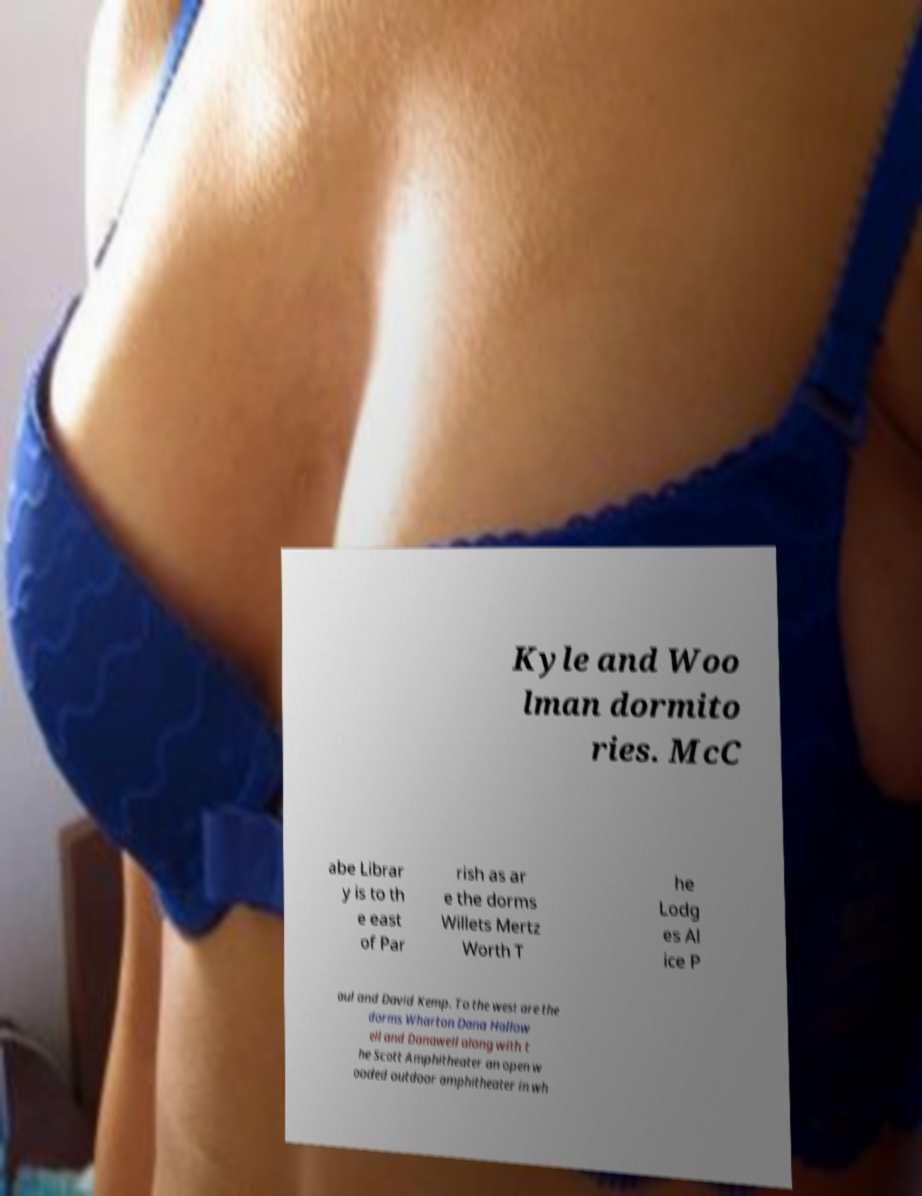Please read and relay the text visible in this image. What does it say? Kyle and Woo lman dormito ries. McC abe Librar y is to th e east of Par rish as ar e the dorms Willets Mertz Worth T he Lodg es Al ice P aul and David Kemp. To the west are the dorms Wharton Dana Hallow ell and Danawell along with t he Scott Amphitheater an open w ooded outdoor amphitheater in wh 